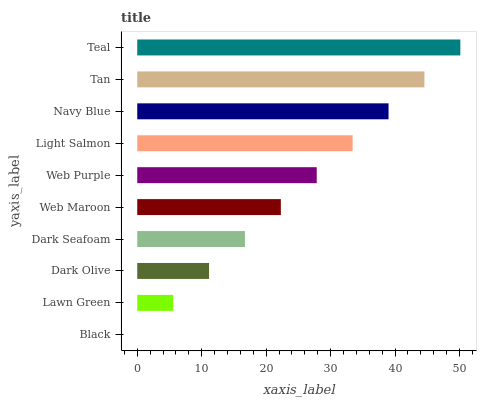Is Black the minimum?
Answer yes or no. Yes. Is Teal the maximum?
Answer yes or no. Yes. Is Lawn Green the minimum?
Answer yes or no. No. Is Lawn Green the maximum?
Answer yes or no. No. Is Lawn Green greater than Black?
Answer yes or no. Yes. Is Black less than Lawn Green?
Answer yes or no. Yes. Is Black greater than Lawn Green?
Answer yes or no. No. Is Lawn Green less than Black?
Answer yes or no. No. Is Web Purple the high median?
Answer yes or no. Yes. Is Web Maroon the low median?
Answer yes or no. Yes. Is Web Maroon the high median?
Answer yes or no. No. Is Black the low median?
Answer yes or no. No. 